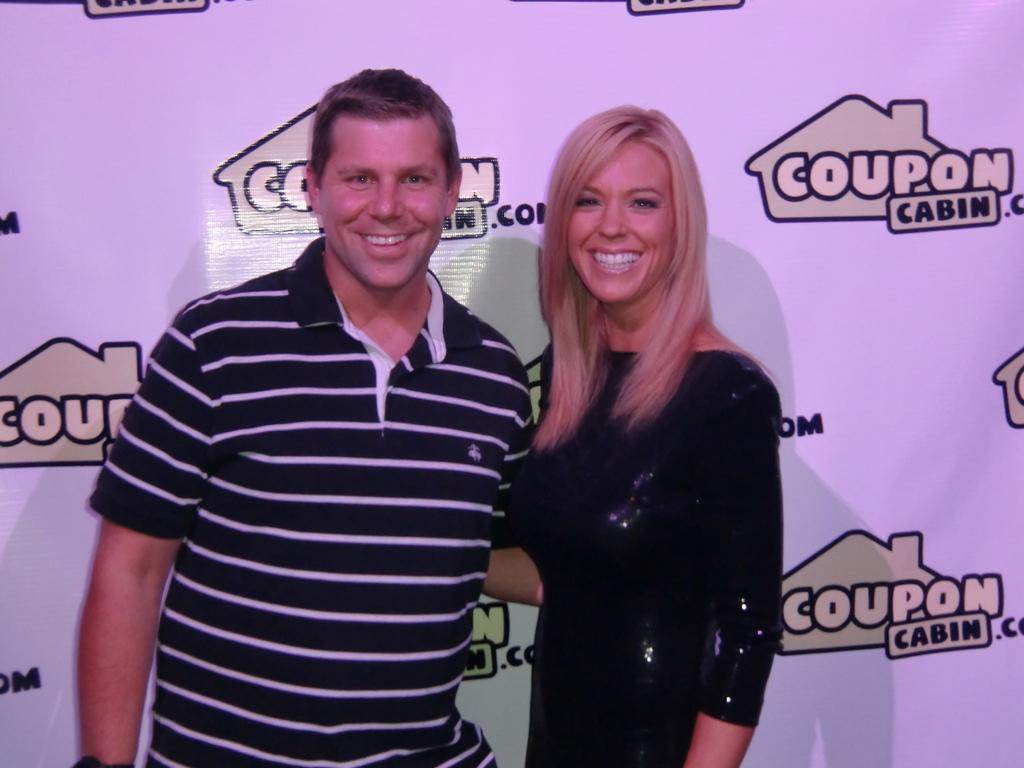How many people are in the image? There are persons in the image, but the exact number is not specified. What can be seen behind the persons in the image? The persons are in front of a sponsor board. What type of pail is being used by the persons in the image? There is no pail present in the image. 